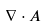Convert formula to latex. <formula><loc_0><loc_0><loc_500><loc_500>\nabla \cdot A</formula> 